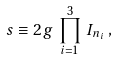<formula> <loc_0><loc_0><loc_500><loc_500>s \equiv 2 g \, \prod _ { i = 1 } ^ { 3 } \, I _ { n _ { i } } \, ,</formula> 